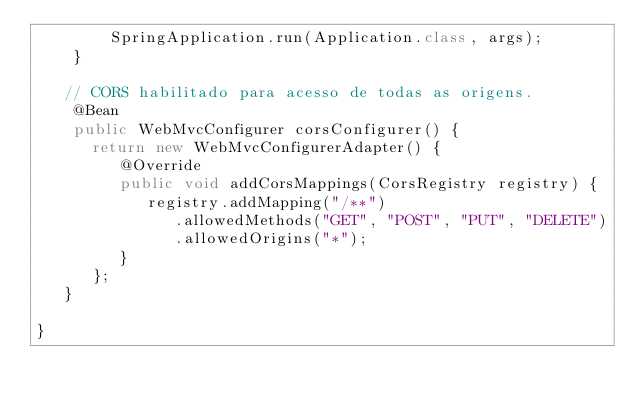<code> <loc_0><loc_0><loc_500><loc_500><_Java_>		SpringApplication.run(Application.class, args);
	}

   // CORS habilitado para acesso de todas as origens.
	@Bean
  	public WebMvcConfigurer corsConfigurer() {
      return new WebMvcConfigurerAdapter() {
         @Override
         public void addCorsMappings(CorsRegistry registry) {
            registry.addMapping("/**")
               .allowedMethods("GET", "POST", "PUT", "DELETE")
               .allowedOrigins("*");
         }
      };
   }

}
</code> 